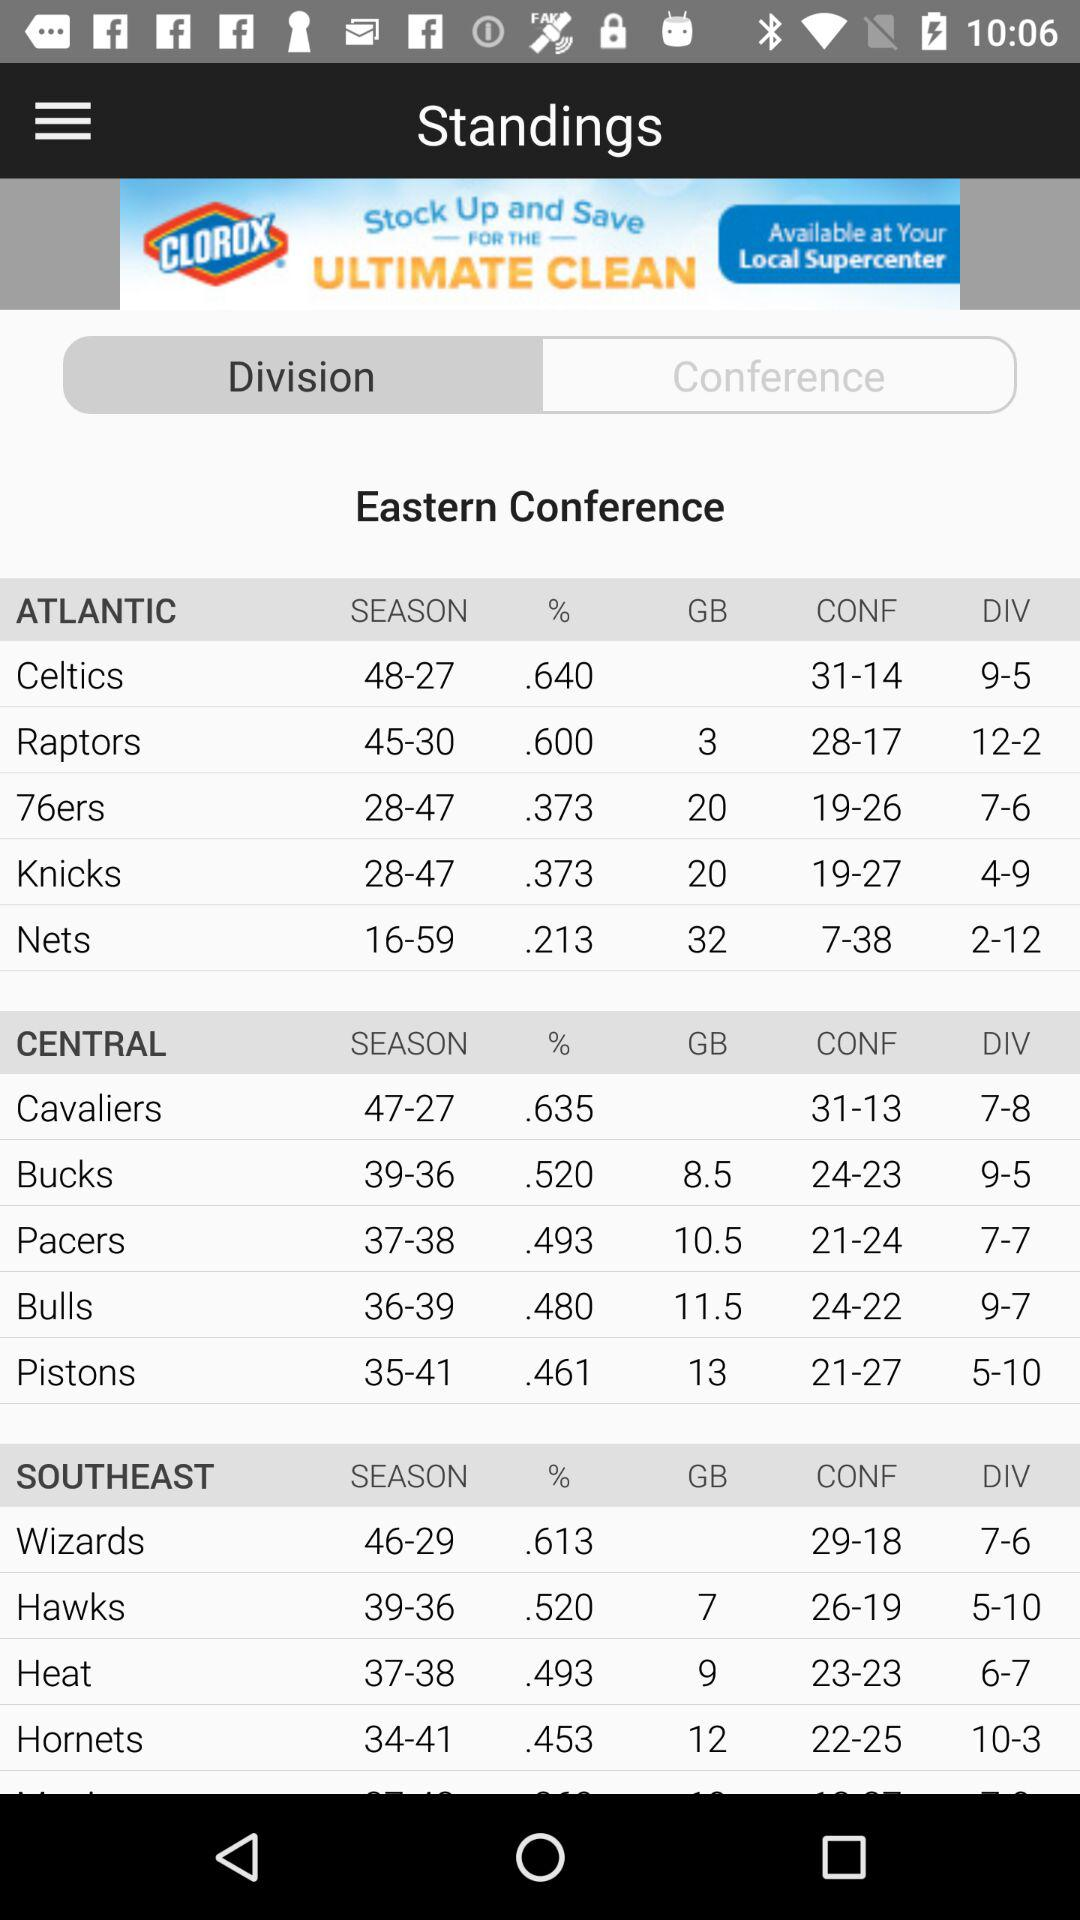Which tab is selected? The selected tab is "Division". 